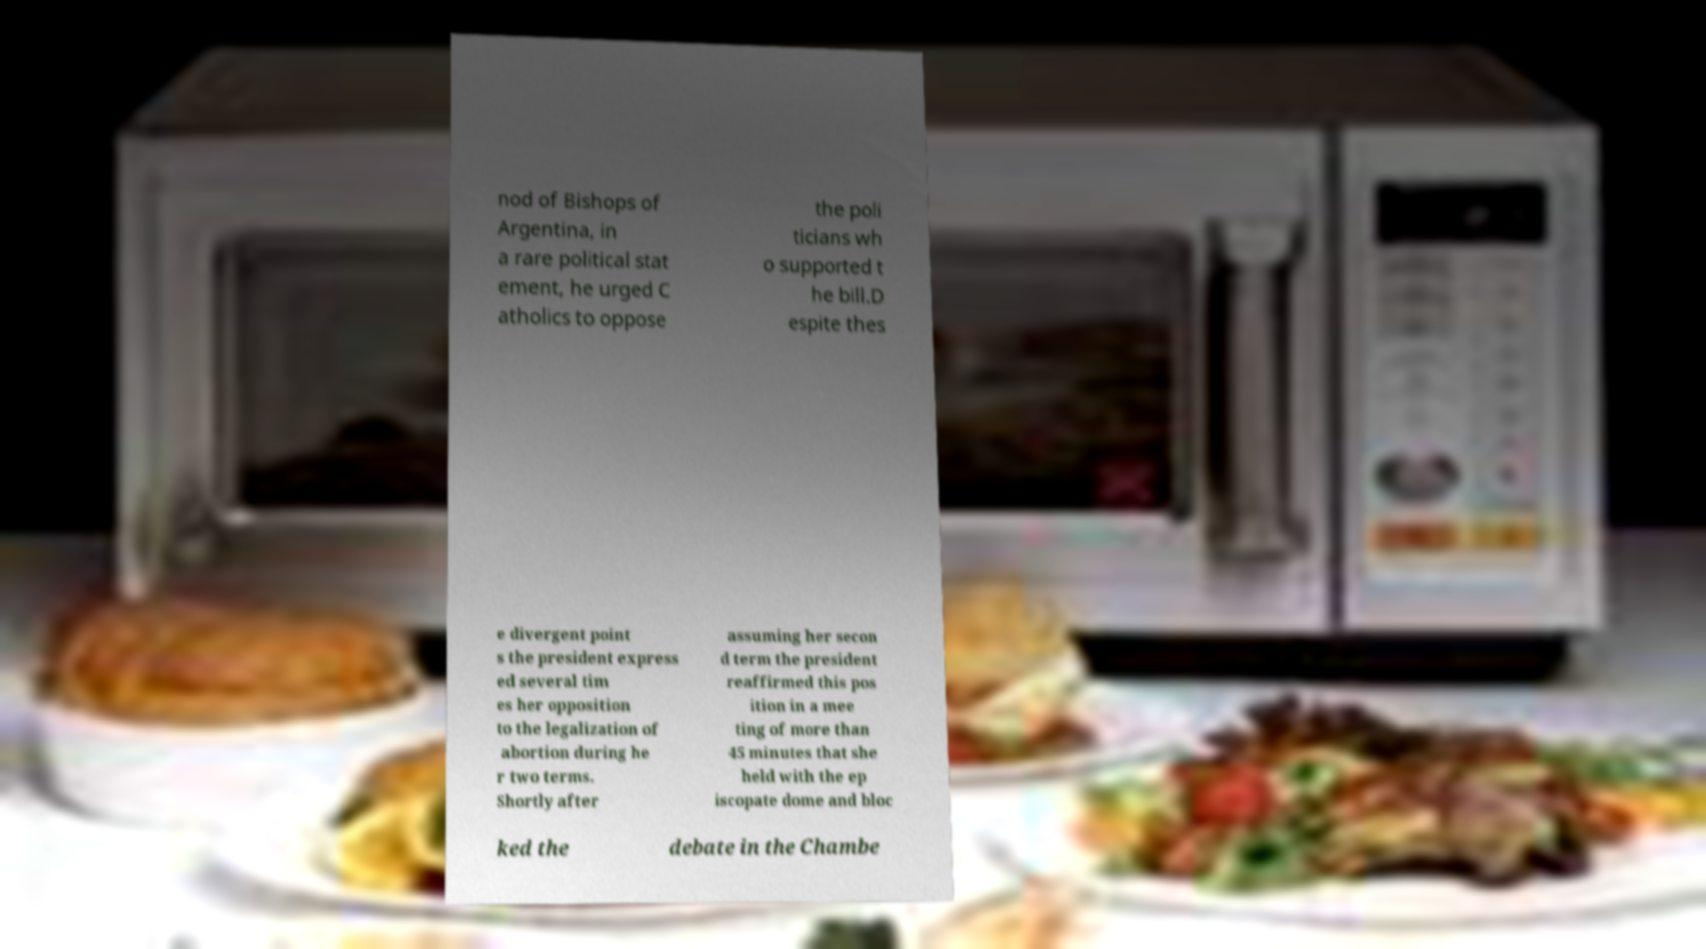I need the written content from this picture converted into text. Can you do that? nod of Bishops of Argentina, in a rare political stat ement, he urged C atholics to oppose the poli ticians wh o supported t he bill.D espite thes e divergent point s the president express ed several tim es her opposition to the legalization of abortion during he r two terms. Shortly after assuming her secon d term the president reaffirmed this pos ition in a mee ting of more than 45 minutes that she held with the ep iscopate dome and bloc ked the debate in the Chambe 